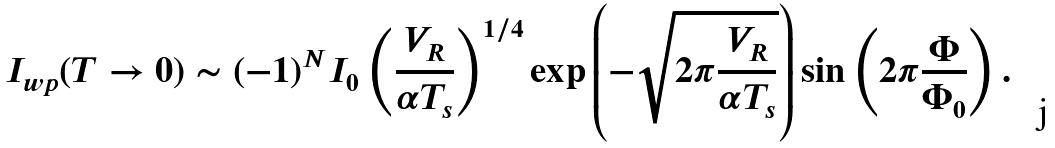Convert formula to latex. <formula><loc_0><loc_0><loc_500><loc_500>I _ { w p } ( T \rightarrow 0 ) \sim ( - 1 ) ^ { N } I _ { 0 } \left ( \frac { V _ { R } } { \alpha T _ { s } } \right ) ^ { 1 / 4 } \exp \left ( - \sqrt { 2 \pi \frac { V _ { R } } { \alpha T _ { s } } } \right ) \sin \left ( 2 \pi \frac { \Phi } { \Phi _ { 0 } } \right ) .</formula> 